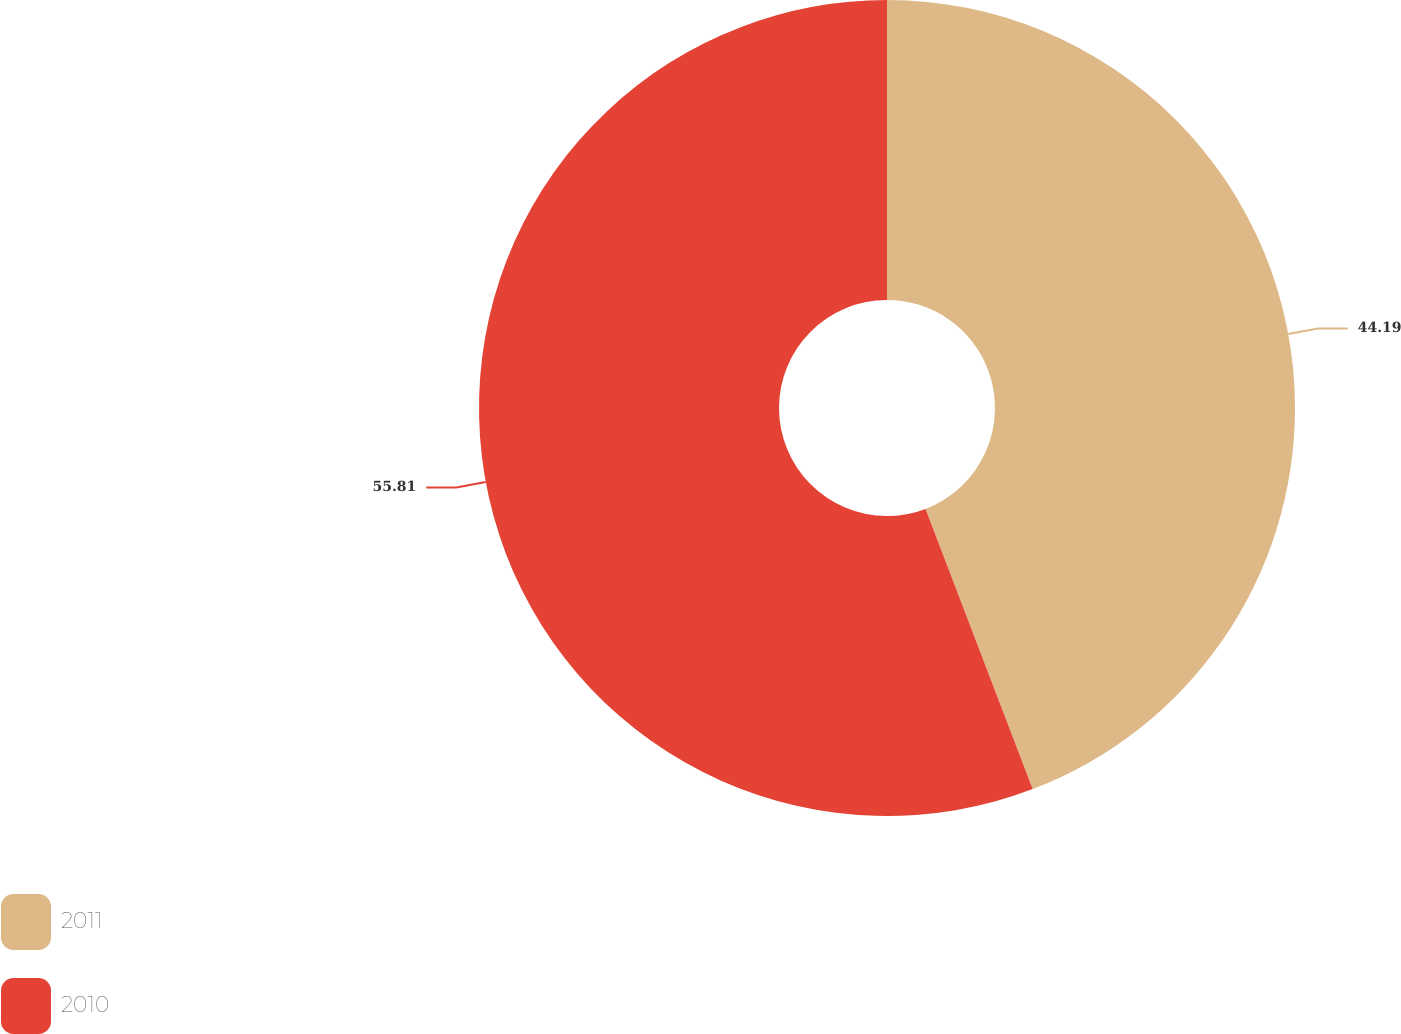Convert chart to OTSL. <chart><loc_0><loc_0><loc_500><loc_500><pie_chart><fcel>2011<fcel>2010<nl><fcel>44.19%<fcel>55.81%<nl></chart> 